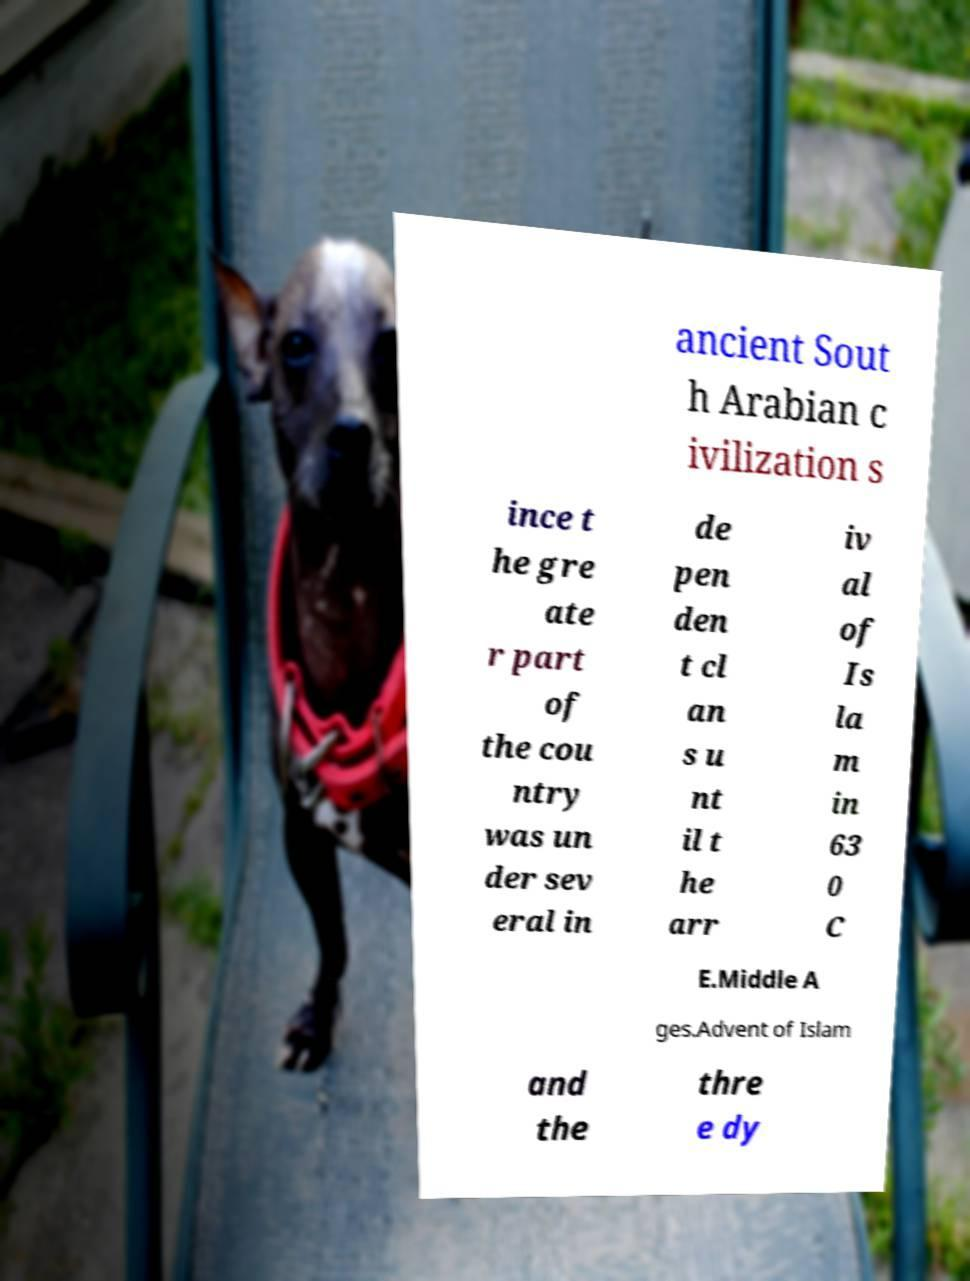Please read and relay the text visible in this image. What does it say? ancient Sout h Arabian c ivilization s ince t he gre ate r part of the cou ntry was un der sev eral in de pen den t cl an s u nt il t he arr iv al of Is la m in 63 0 C E.Middle A ges.Advent of Islam and the thre e dy 